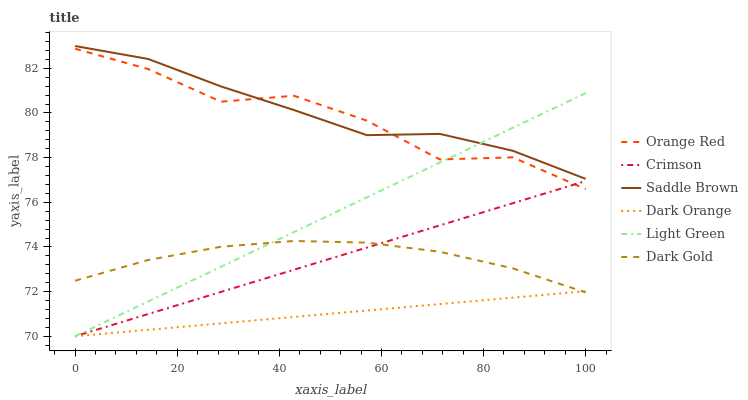Does Dark Orange have the minimum area under the curve?
Answer yes or no. Yes. Does Saddle Brown have the maximum area under the curve?
Answer yes or no. Yes. Does Dark Gold have the minimum area under the curve?
Answer yes or no. No. Does Dark Gold have the maximum area under the curve?
Answer yes or no. No. Is Dark Orange the smoothest?
Answer yes or no. Yes. Is Orange Red the roughest?
Answer yes or no. Yes. Is Dark Gold the smoothest?
Answer yes or no. No. Is Dark Gold the roughest?
Answer yes or no. No. Does Dark Orange have the lowest value?
Answer yes or no. Yes. Does Dark Gold have the lowest value?
Answer yes or no. No. Does Saddle Brown have the highest value?
Answer yes or no. Yes. Does Dark Gold have the highest value?
Answer yes or no. No. Is Dark Orange less than Saddle Brown?
Answer yes or no. Yes. Is Orange Red greater than Dark Gold?
Answer yes or no. Yes. Does Light Green intersect Dark Gold?
Answer yes or no. Yes. Is Light Green less than Dark Gold?
Answer yes or no. No. Is Light Green greater than Dark Gold?
Answer yes or no. No. Does Dark Orange intersect Saddle Brown?
Answer yes or no. No. 